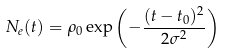Convert formula to latex. <formula><loc_0><loc_0><loc_500><loc_500>N _ { e } ( t ) = \rho _ { 0 } \exp { \left ( - \frac { ( t - t _ { 0 } ) ^ { 2 } } { 2 \sigma ^ { 2 } } \right ) }</formula> 